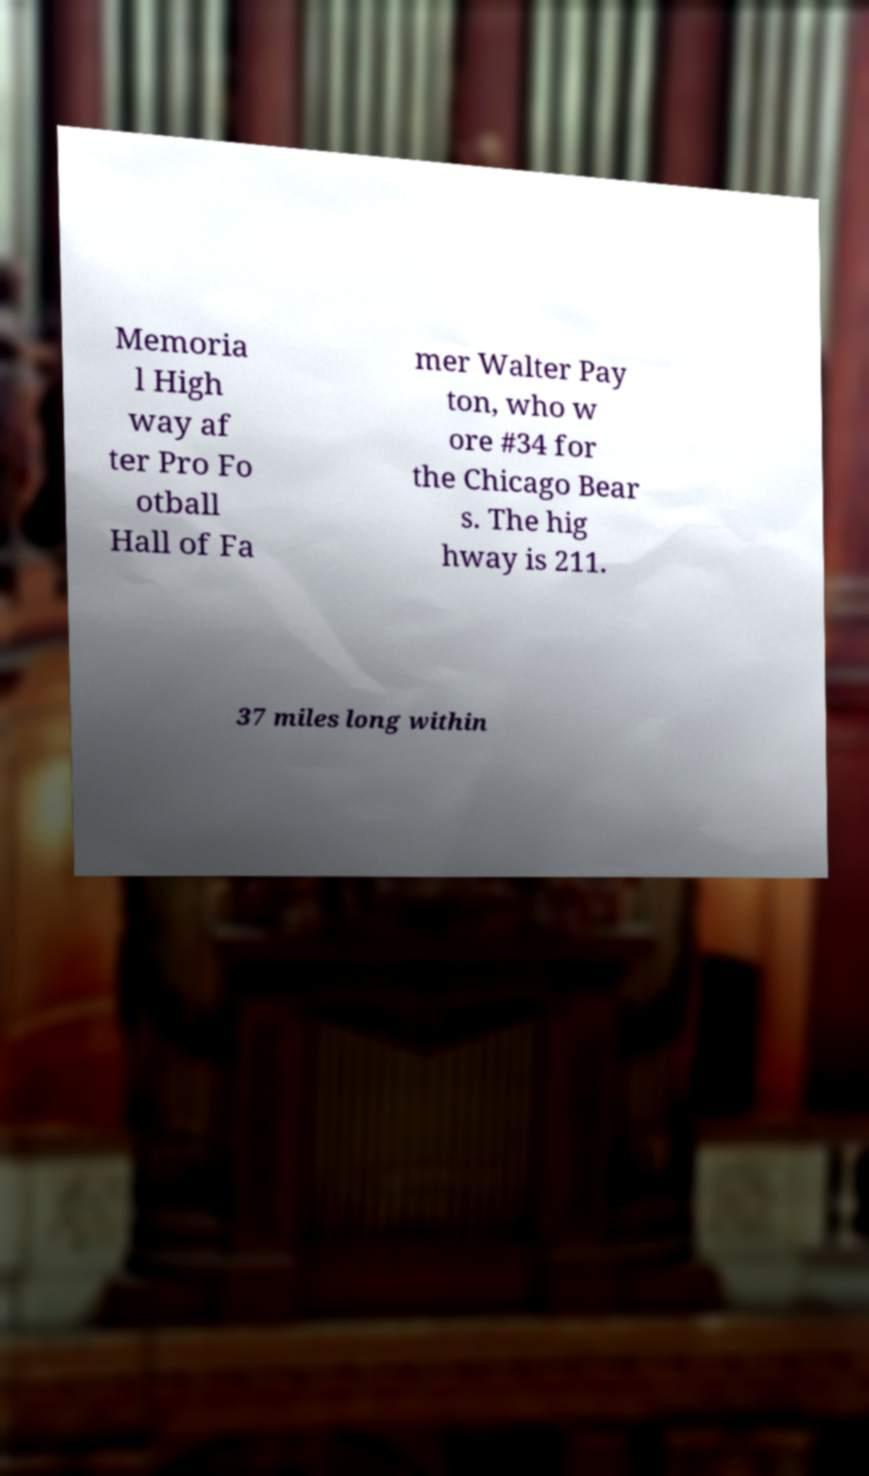Please read and relay the text visible in this image. What does it say? Memoria l High way af ter Pro Fo otball Hall of Fa mer Walter Pay ton, who w ore #34 for the Chicago Bear s. The hig hway is 211. 37 miles long within 